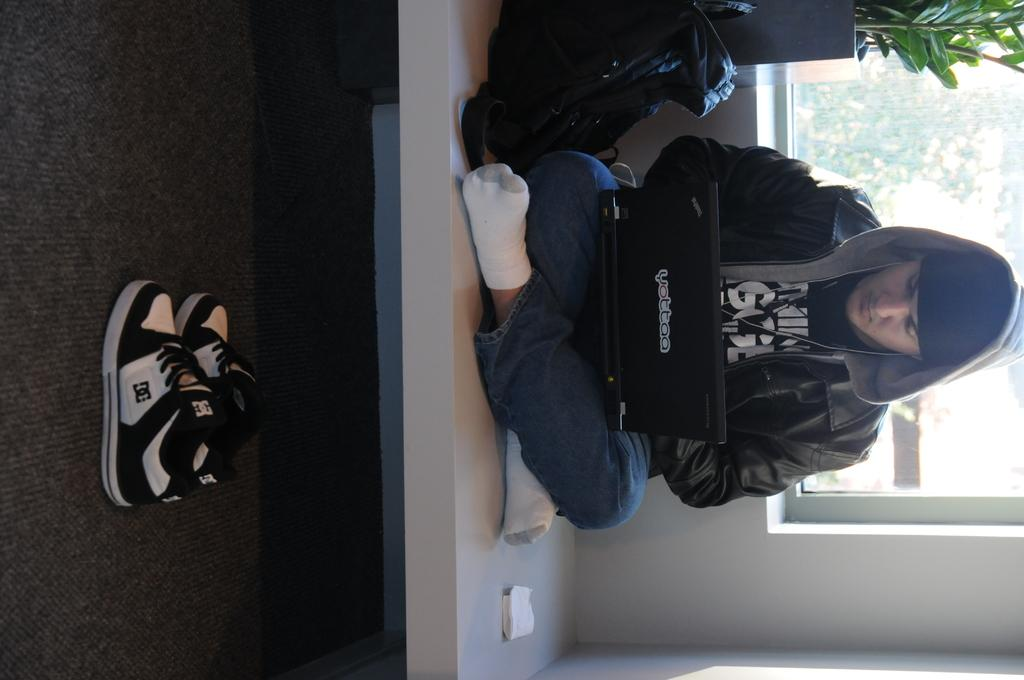What is the man in the foreground of the image doing? The man is sitting on a surface with a laptop in the foreground of the image. What can be seen on the left side of the image? There are shoes on a carpet on the left side of the image. What is present on the right side of the image? There is a wall, a window, a plant, and a bag on the right side of the image. What type of leather material can be seen on the man's shoes in the image? There is no mention of leather material or shoes on the man's feet in the image. What kind of pipe is visible in the image? There is no pipe present in the image. 